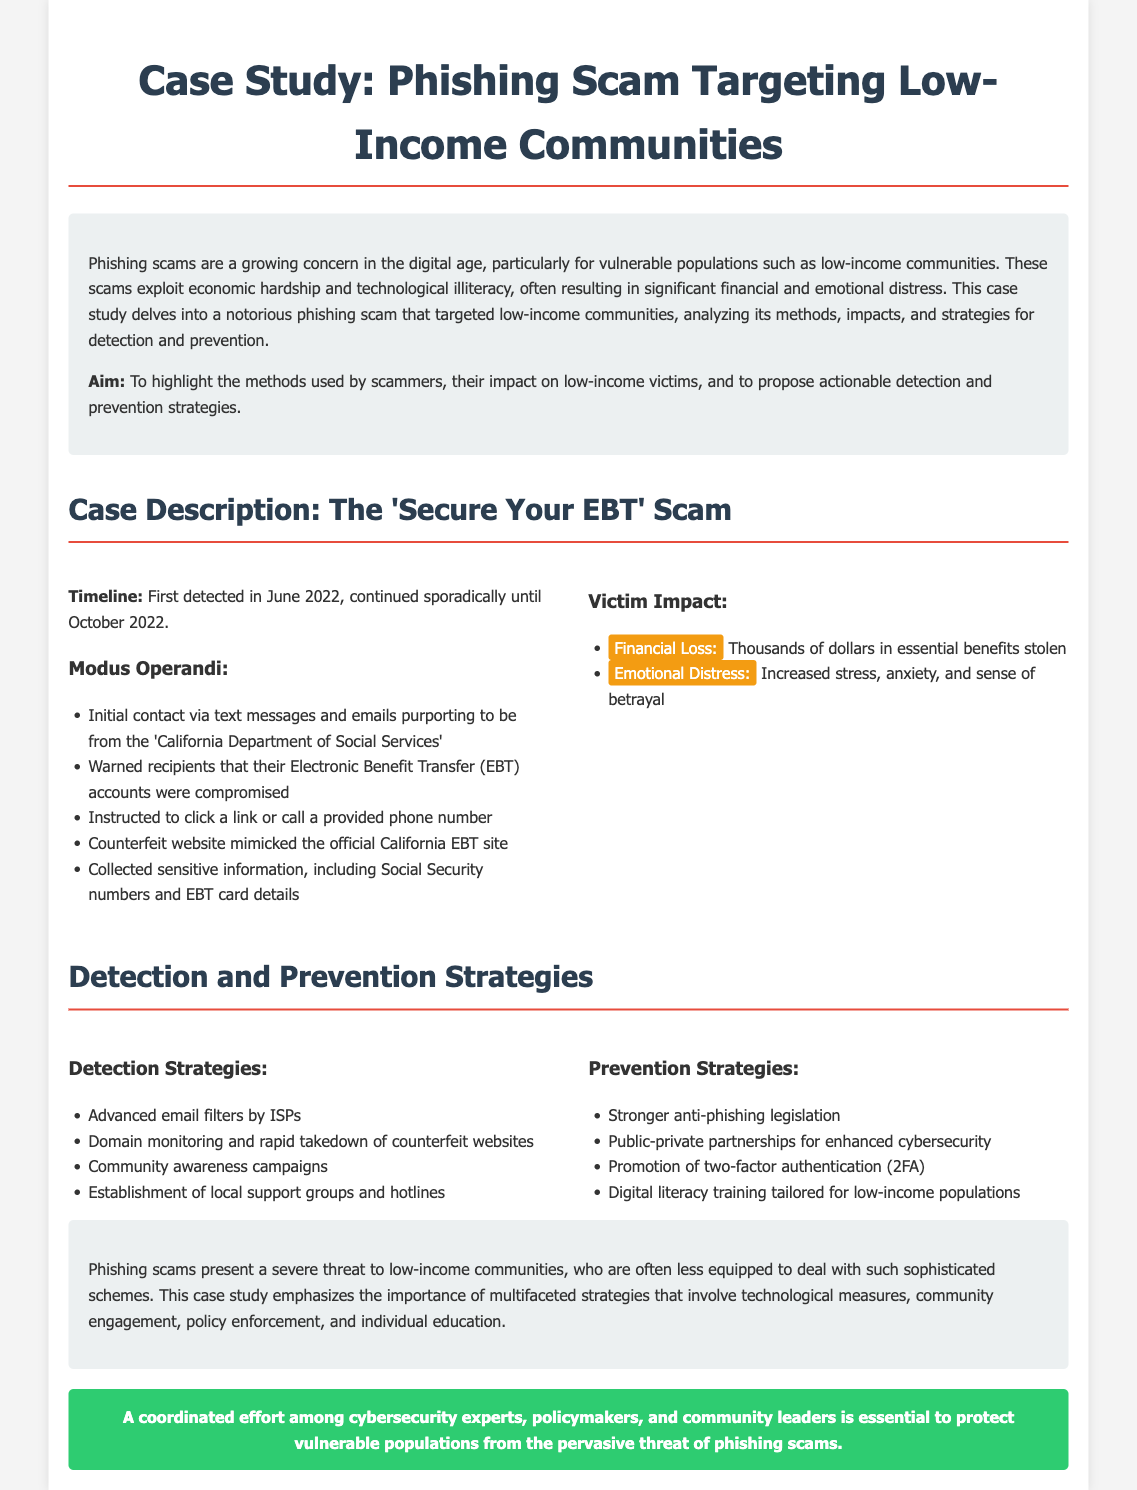what is the name of the phishing scam discussed? The phishing scam in the document is referred to as the 'Secure Your EBT' scam.
Answer: 'Secure Your EBT' when was the phishing scam first detected? The document states that the scam was first detected in June 2022.
Answer: June 2022 how many strategies are listed for detection? The document provides a total of four strategies under the detection section.
Answer: Four what type of emotional impact did the victims experience? The document mentions increased stress, anxiety, and sense of betrayal as emotional impacts on victims.
Answer: Increased stress, anxiety, and sense of betrayal what is one proposed prevention strategy? The document includes promoting two-factor authentication (2FA) as a proposed prevention strategy.
Answer: Promotion of two-factor authentication (2FA) what organization did the scammers impersonate? Scammers pretended to be from the California Department of Social Services.
Answer: California Department of Social Services what was the main goal of the case study? The main aim of the case study is to highlight the methods used by scammers and propose actionable strategies.
Answer: Highlight methods and propose strategies how long did the phishing scam continue? The document indicates that the scam continued sporadically until October 2022.
Answer: Until October 2022 